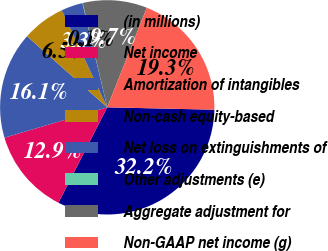Convert chart. <chart><loc_0><loc_0><loc_500><loc_500><pie_chart><fcel>(in millions)<fcel>Net income<fcel>Amortization of intangibles<fcel>Non-cash equity-based<fcel>Net loss on extinguishments of<fcel>Other adjustments (e)<fcel>Aggregate adjustment for<fcel>Non-GAAP net income (g)<nl><fcel>32.17%<fcel>12.9%<fcel>16.11%<fcel>6.48%<fcel>3.26%<fcel>0.05%<fcel>9.69%<fcel>19.33%<nl></chart> 